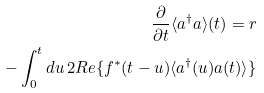<formula> <loc_0><loc_0><loc_500><loc_500>\frac { \partial } { \partial t } \langle a ^ { \dag } a \rangle ( t ) = r \\ - \int _ { 0 } ^ { t } d u \, 2 R e \{ f ^ { * } ( t - u ) \langle a ^ { \dag } ( u ) a ( t ) \rangle \}</formula> 